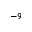<formula> <loc_0><loc_0><loc_500><loc_500>^ { - 9 }</formula> 